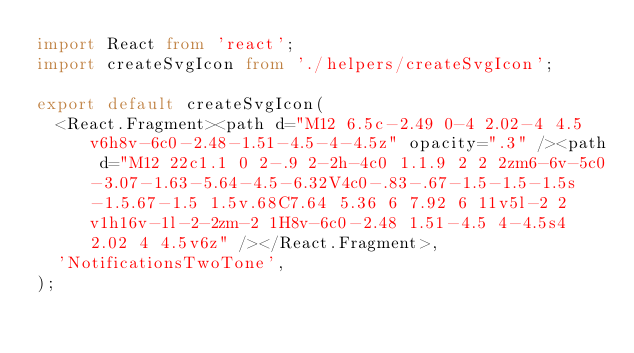Convert code to text. <code><loc_0><loc_0><loc_500><loc_500><_TypeScript_>import React from 'react';
import createSvgIcon from './helpers/createSvgIcon';

export default createSvgIcon(
  <React.Fragment><path d="M12 6.5c-2.49 0-4 2.02-4 4.5v6h8v-6c0-2.48-1.51-4.5-4-4.5z" opacity=".3" /><path d="M12 22c1.1 0 2-.9 2-2h-4c0 1.1.9 2 2 2zm6-6v-5c0-3.07-1.63-5.64-4.5-6.32V4c0-.83-.67-1.5-1.5-1.5s-1.5.67-1.5 1.5v.68C7.64 5.36 6 7.92 6 11v5l-2 2v1h16v-1l-2-2zm-2 1H8v-6c0-2.48 1.51-4.5 4-4.5s4 2.02 4 4.5v6z" /></React.Fragment>,
  'NotificationsTwoTone',
);
</code> 